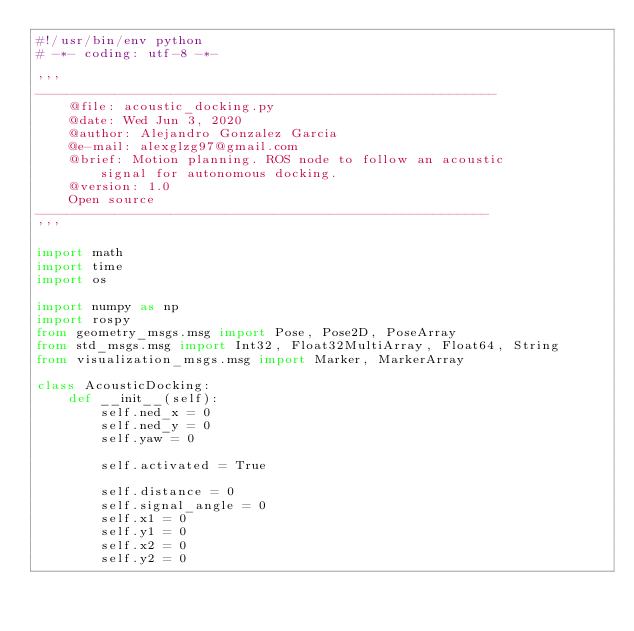<code> <loc_0><loc_0><loc_500><loc_500><_Python_>#!/usr/bin/env python
# -*- coding: utf-8 -*-

'''
----------------------------------------------------------
    @file: acoustic_docking.py
    @date: Wed Jun 3, 2020
    @author: Alejandro Gonzalez Garcia
    @e-mail: alexglzg97@gmail.com
    @brief: Motion planning. ROS node to follow an acoustic
        signal for autonomous docking.
    @version: 1.0
    Open source
---------------------------------------------------------
'''

import math
import time
import os

import numpy as np
import rospy
from geometry_msgs.msg import Pose, Pose2D, PoseArray
from std_msgs.msg import Int32, Float32MultiArray, Float64, String
from visualization_msgs.msg import Marker, MarkerArray

class AcousticDocking:
    def __init__(self):
        self.ned_x = 0
        self.ned_y = 0
        self.yaw = 0

        self.activated = True

        self.distance = 0
        self.signal_angle = 0
        self.x1 = 0
        self.y1 = 0
        self.x2 = 0
        self.y2 = 0</code> 